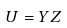Convert formula to latex. <formula><loc_0><loc_0><loc_500><loc_500>U = Y Z</formula> 